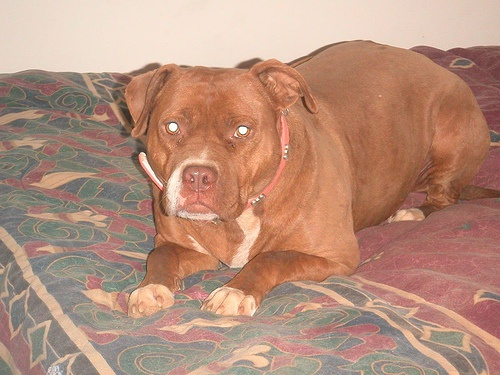Describe the objects in this image and their specific colors. I can see bed in lightgray, brown, darkgray, tan, and gray tones and dog in lightgray, salmon, and brown tones in this image. 